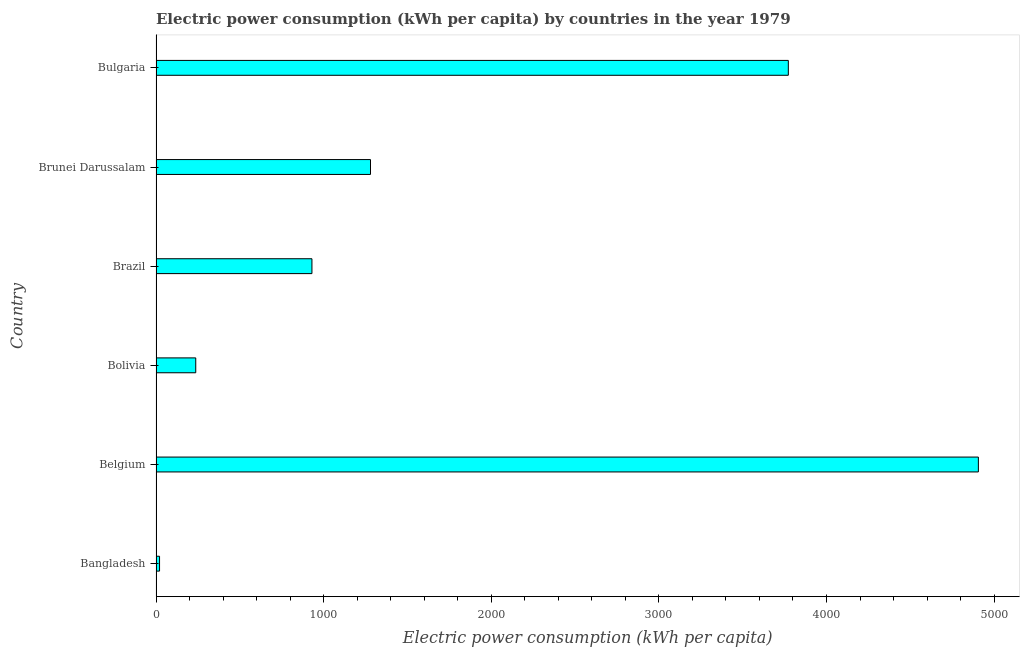Does the graph contain grids?
Make the answer very short. No. What is the title of the graph?
Provide a short and direct response. Electric power consumption (kWh per capita) by countries in the year 1979. What is the label or title of the X-axis?
Offer a very short reply. Electric power consumption (kWh per capita). What is the electric power consumption in Brazil?
Offer a very short reply. 930.15. Across all countries, what is the maximum electric power consumption?
Your response must be concise. 4906.09. Across all countries, what is the minimum electric power consumption?
Keep it short and to the point. 20.99. In which country was the electric power consumption maximum?
Ensure brevity in your answer.  Belgium. In which country was the electric power consumption minimum?
Provide a short and direct response. Bangladesh. What is the sum of the electric power consumption?
Make the answer very short. 1.11e+04. What is the difference between the electric power consumption in Bangladesh and Bolivia?
Offer a very short reply. -215.98. What is the average electric power consumption per country?
Offer a terse response. 1857.67. What is the median electric power consumption?
Your response must be concise. 1104.85. In how many countries, is the electric power consumption greater than 3400 kWh per capita?
Provide a succinct answer. 2. What is the ratio of the electric power consumption in Belgium to that in Brazil?
Provide a succinct answer. 5.27. Is the electric power consumption in Belgium less than that in Brunei Darussalam?
Keep it short and to the point. No. Is the difference between the electric power consumption in Belgium and Bolivia greater than the difference between any two countries?
Offer a terse response. No. What is the difference between the highest and the second highest electric power consumption?
Provide a succinct answer. 1133.8. Is the sum of the electric power consumption in Belgium and Bulgaria greater than the maximum electric power consumption across all countries?
Your answer should be very brief. Yes. What is the difference between the highest and the lowest electric power consumption?
Ensure brevity in your answer.  4885.1. How many bars are there?
Provide a succinct answer. 6. What is the difference between two consecutive major ticks on the X-axis?
Your response must be concise. 1000. Are the values on the major ticks of X-axis written in scientific E-notation?
Ensure brevity in your answer.  No. What is the Electric power consumption (kWh per capita) of Bangladesh?
Offer a very short reply. 20.99. What is the Electric power consumption (kWh per capita) in Belgium?
Provide a short and direct response. 4906.09. What is the Electric power consumption (kWh per capita) of Bolivia?
Offer a terse response. 236.97. What is the Electric power consumption (kWh per capita) of Brazil?
Your response must be concise. 930.15. What is the Electric power consumption (kWh per capita) in Brunei Darussalam?
Provide a short and direct response. 1279.54. What is the Electric power consumption (kWh per capita) in Bulgaria?
Offer a terse response. 3772.29. What is the difference between the Electric power consumption (kWh per capita) in Bangladesh and Belgium?
Your response must be concise. -4885.1. What is the difference between the Electric power consumption (kWh per capita) in Bangladesh and Bolivia?
Your answer should be very brief. -215.98. What is the difference between the Electric power consumption (kWh per capita) in Bangladesh and Brazil?
Offer a terse response. -909.17. What is the difference between the Electric power consumption (kWh per capita) in Bangladesh and Brunei Darussalam?
Offer a terse response. -1258.55. What is the difference between the Electric power consumption (kWh per capita) in Bangladesh and Bulgaria?
Give a very brief answer. -3751.3. What is the difference between the Electric power consumption (kWh per capita) in Belgium and Bolivia?
Offer a terse response. 4669.12. What is the difference between the Electric power consumption (kWh per capita) in Belgium and Brazil?
Offer a terse response. 3975.93. What is the difference between the Electric power consumption (kWh per capita) in Belgium and Brunei Darussalam?
Ensure brevity in your answer.  3626.55. What is the difference between the Electric power consumption (kWh per capita) in Belgium and Bulgaria?
Your answer should be very brief. 1133.8. What is the difference between the Electric power consumption (kWh per capita) in Bolivia and Brazil?
Offer a very short reply. -693.19. What is the difference between the Electric power consumption (kWh per capita) in Bolivia and Brunei Darussalam?
Your answer should be very brief. -1042.57. What is the difference between the Electric power consumption (kWh per capita) in Bolivia and Bulgaria?
Keep it short and to the point. -3535.32. What is the difference between the Electric power consumption (kWh per capita) in Brazil and Brunei Darussalam?
Provide a succinct answer. -349.38. What is the difference between the Electric power consumption (kWh per capita) in Brazil and Bulgaria?
Your answer should be very brief. -2842.13. What is the difference between the Electric power consumption (kWh per capita) in Brunei Darussalam and Bulgaria?
Provide a succinct answer. -2492.75. What is the ratio of the Electric power consumption (kWh per capita) in Bangladesh to that in Belgium?
Offer a terse response. 0. What is the ratio of the Electric power consumption (kWh per capita) in Bangladesh to that in Bolivia?
Ensure brevity in your answer.  0.09. What is the ratio of the Electric power consumption (kWh per capita) in Bangladesh to that in Brazil?
Your answer should be very brief. 0.02. What is the ratio of the Electric power consumption (kWh per capita) in Bangladesh to that in Brunei Darussalam?
Provide a succinct answer. 0.02. What is the ratio of the Electric power consumption (kWh per capita) in Bangladesh to that in Bulgaria?
Provide a short and direct response. 0.01. What is the ratio of the Electric power consumption (kWh per capita) in Belgium to that in Bolivia?
Offer a very short reply. 20.7. What is the ratio of the Electric power consumption (kWh per capita) in Belgium to that in Brazil?
Make the answer very short. 5.27. What is the ratio of the Electric power consumption (kWh per capita) in Belgium to that in Brunei Darussalam?
Ensure brevity in your answer.  3.83. What is the ratio of the Electric power consumption (kWh per capita) in Belgium to that in Bulgaria?
Offer a terse response. 1.3. What is the ratio of the Electric power consumption (kWh per capita) in Bolivia to that in Brazil?
Provide a short and direct response. 0.26. What is the ratio of the Electric power consumption (kWh per capita) in Bolivia to that in Brunei Darussalam?
Offer a terse response. 0.18. What is the ratio of the Electric power consumption (kWh per capita) in Bolivia to that in Bulgaria?
Provide a short and direct response. 0.06. What is the ratio of the Electric power consumption (kWh per capita) in Brazil to that in Brunei Darussalam?
Your response must be concise. 0.73. What is the ratio of the Electric power consumption (kWh per capita) in Brazil to that in Bulgaria?
Your response must be concise. 0.25. What is the ratio of the Electric power consumption (kWh per capita) in Brunei Darussalam to that in Bulgaria?
Offer a very short reply. 0.34. 